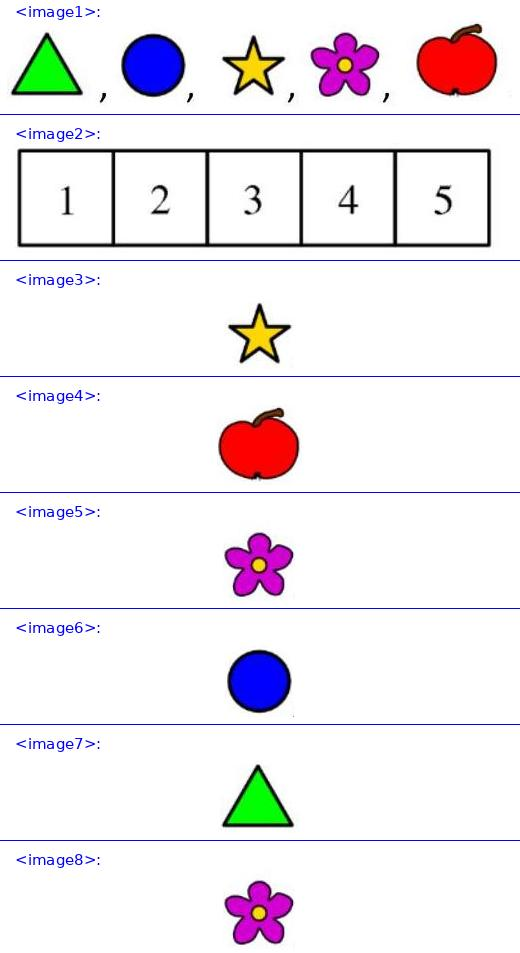<image1> What kind of learning activities could these stickers be used for with young children? These stickers can be excellent resources for a variety of educational activities. For instance, they can be used for color recognition, where children identify and name the colors. Additionally, they could be utilized in teaching shapes and symbols, with each sticker representing a different form or meaning. Furthermore, arranging these stickers on a numbered board like in <image2> can help children practice numbering and spatial arrangement skills. 